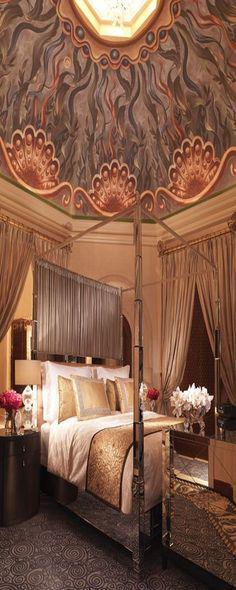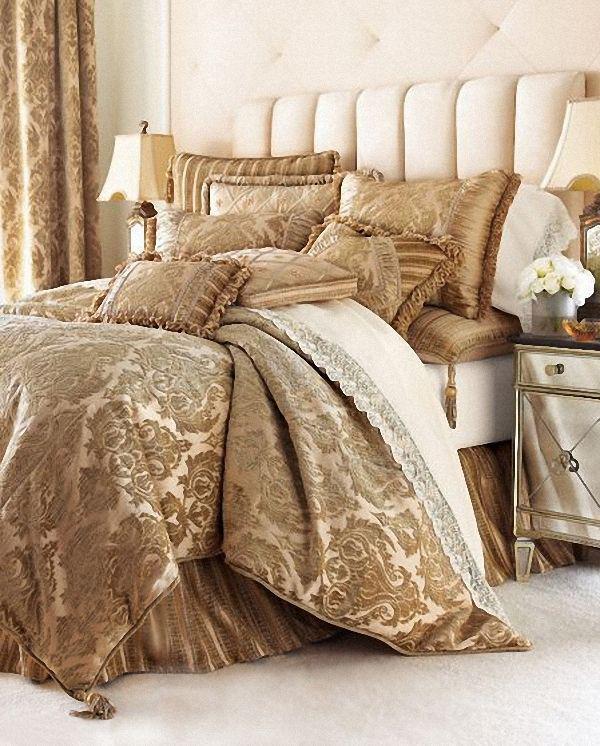The first image is the image on the left, the second image is the image on the right. Analyze the images presented: Is the assertion "In at least one image, no framed wall art is displayed in the bedroom." valid? Answer yes or no. Yes. 